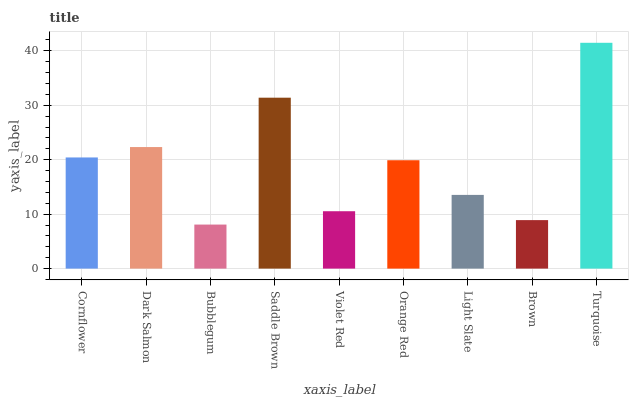Is Bubblegum the minimum?
Answer yes or no. Yes. Is Turquoise the maximum?
Answer yes or no. Yes. Is Dark Salmon the minimum?
Answer yes or no. No. Is Dark Salmon the maximum?
Answer yes or no. No. Is Dark Salmon greater than Cornflower?
Answer yes or no. Yes. Is Cornflower less than Dark Salmon?
Answer yes or no. Yes. Is Cornflower greater than Dark Salmon?
Answer yes or no. No. Is Dark Salmon less than Cornflower?
Answer yes or no. No. Is Orange Red the high median?
Answer yes or no. Yes. Is Orange Red the low median?
Answer yes or no. Yes. Is Light Slate the high median?
Answer yes or no. No. Is Bubblegum the low median?
Answer yes or no. No. 